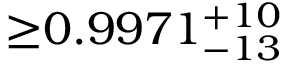<formula> <loc_0><loc_0><loc_500><loc_500>{ \geq } 0 . 9 9 7 1 _ { - 1 3 } ^ { + 1 0 }</formula> 